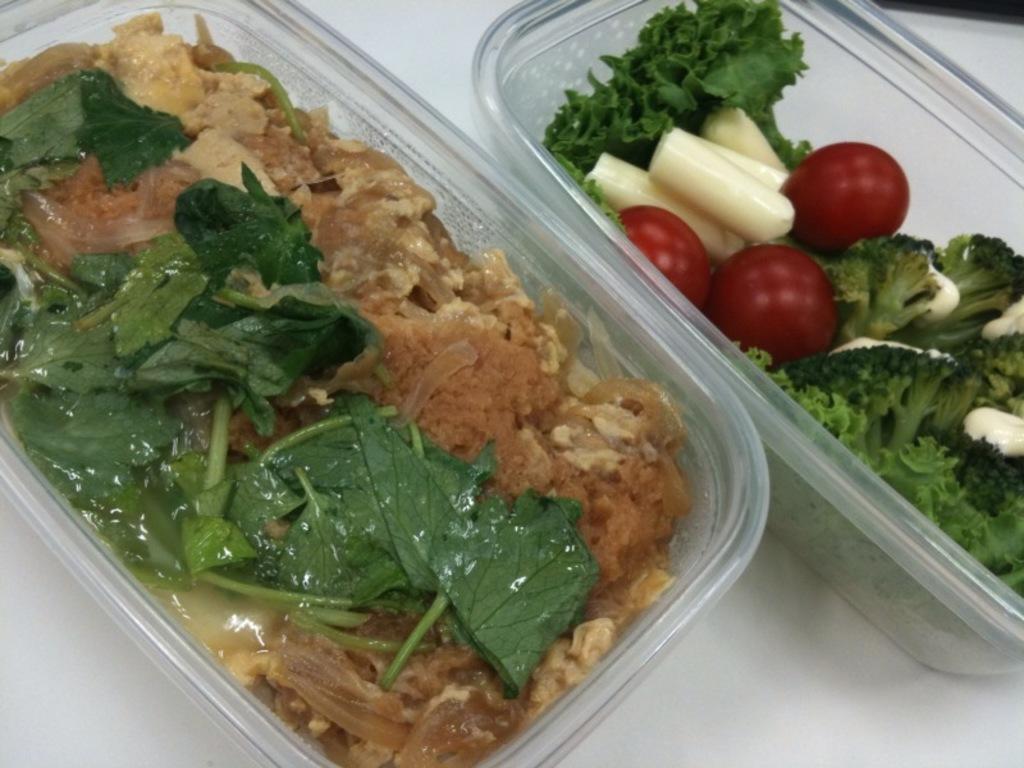Please provide a concise description of this image. As we can see in the image there is a table. On table there are boxes. In boxes there are vegetables. 